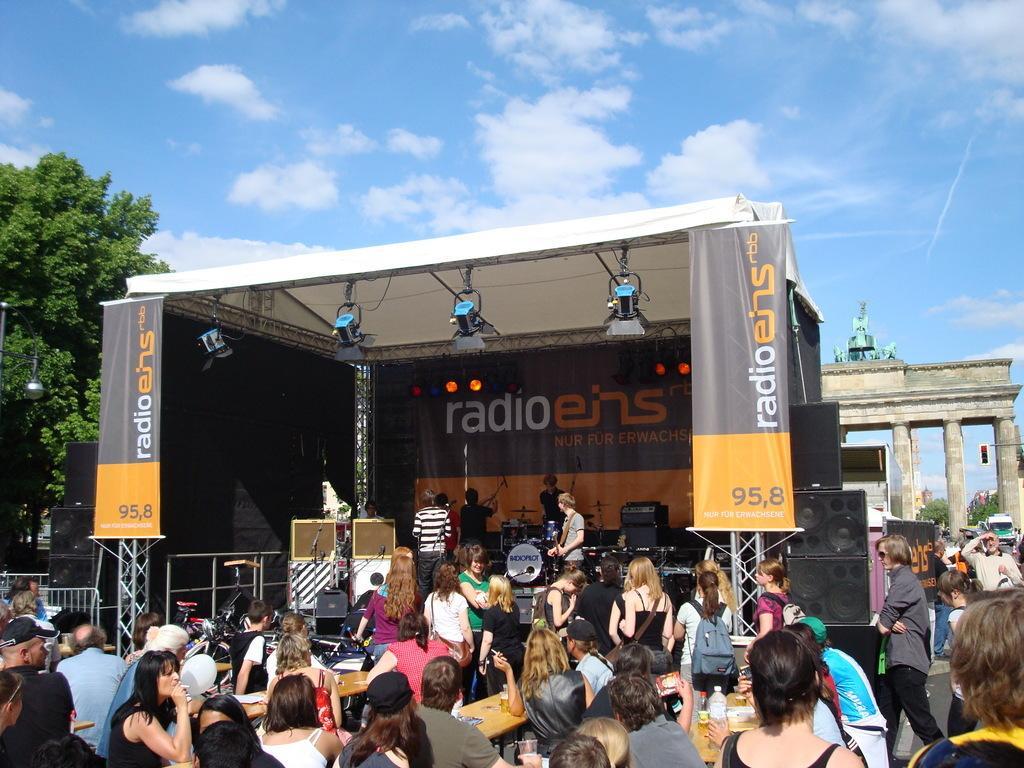Please provide a concise description of this image. In this image I can see few people are sitting and few people are standing. I can see few musical instruments, speakers, banners, few people and few object on the stage. I can see few lights, trees, vehicles and the arch. The sky is in blue and white color. 